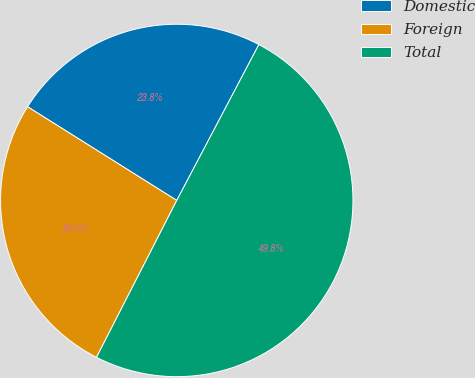<chart> <loc_0><loc_0><loc_500><loc_500><pie_chart><fcel>Domestic<fcel>Foreign<fcel>Total<nl><fcel>23.79%<fcel>26.4%<fcel>49.81%<nl></chart> 